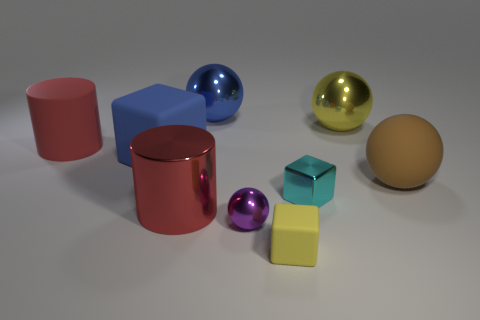What number of matte things are left of the cylinder on the right side of the large red cylinder that is behind the rubber sphere?
Give a very brief answer. 2. There is a yellow thing that is the same material as the big blue sphere; what shape is it?
Your answer should be very brief. Sphere. There is a small thing that is on the left side of the tiny cube that is in front of the big red thing in front of the matte cylinder; what is it made of?
Offer a very short reply. Metal. What number of objects are either shiny objects behind the tiny cyan thing or big gray cylinders?
Give a very brief answer. 2. What number of other objects are the same shape as the red matte object?
Offer a very short reply. 1. Is the number of big blue metallic spheres behind the cyan thing greater than the number of small gray balls?
Keep it short and to the point. Yes. What size is the yellow metallic object that is the same shape as the purple object?
Give a very brief answer. Large. The blue metal thing has what shape?
Offer a terse response. Sphere. What is the shape of the yellow rubber thing that is the same size as the purple shiny thing?
Your response must be concise. Cube. Is there any other thing that is the same color as the big matte cube?
Make the answer very short. Yes. 